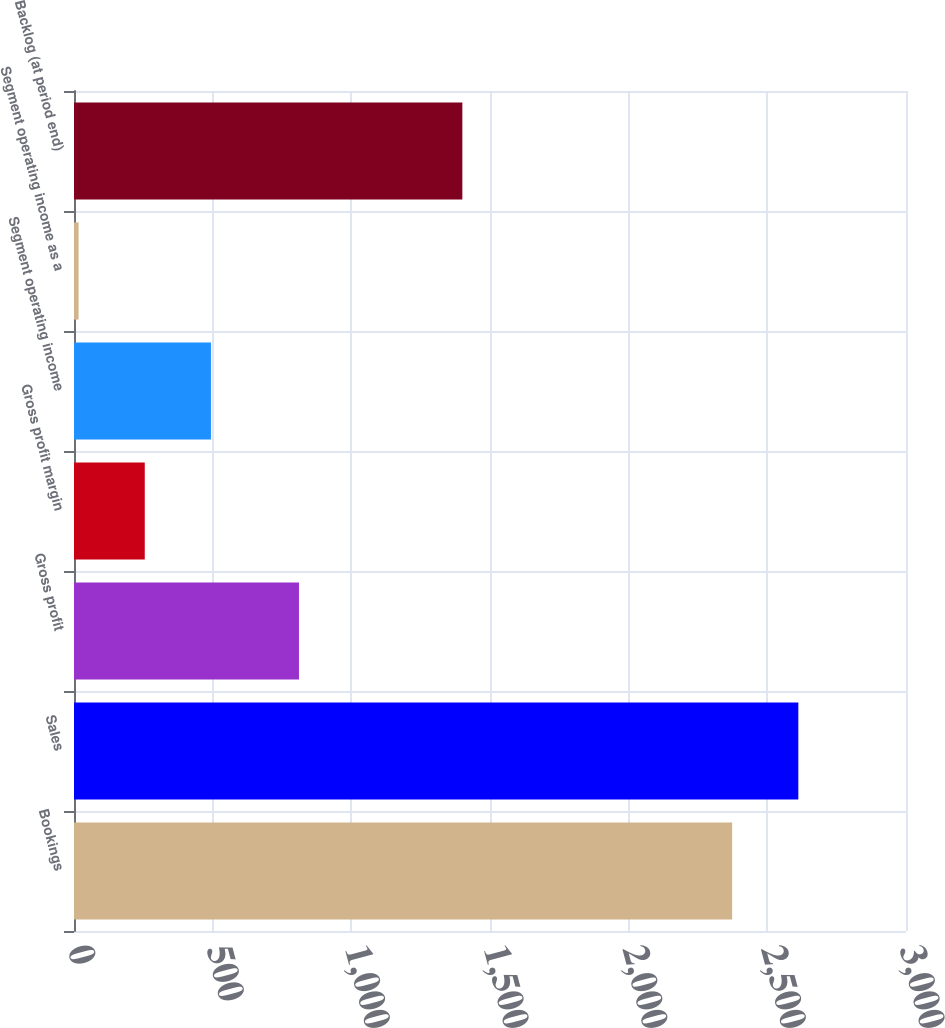Convert chart. <chart><loc_0><loc_0><loc_500><loc_500><bar_chart><fcel>Bookings<fcel>Sales<fcel>Gross profit<fcel>Gross profit margin<fcel>Segment operating income<fcel>Segment operating income as a<fcel>Backlog (at period end)<nl><fcel>2373.1<fcel>2611.76<fcel>811.2<fcel>255.16<fcel>493.82<fcel>16.5<fcel>1400.3<nl></chart> 